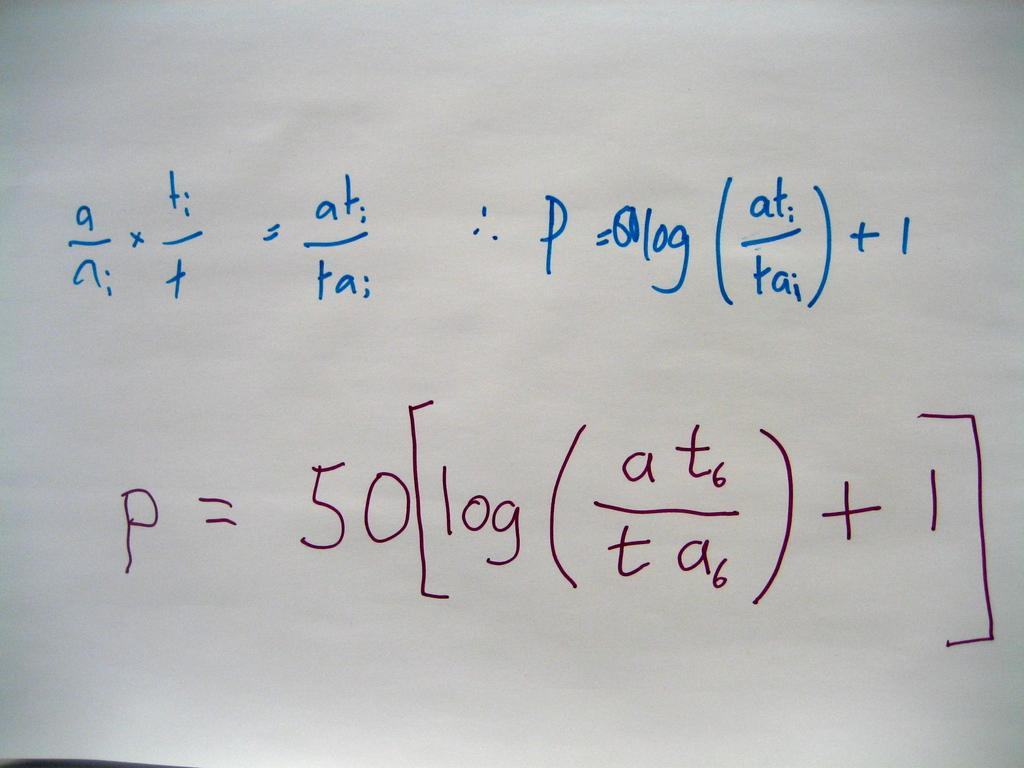<image>
Create a compact narrative representing the image presented. A very long math equation starting with the letter "a". 